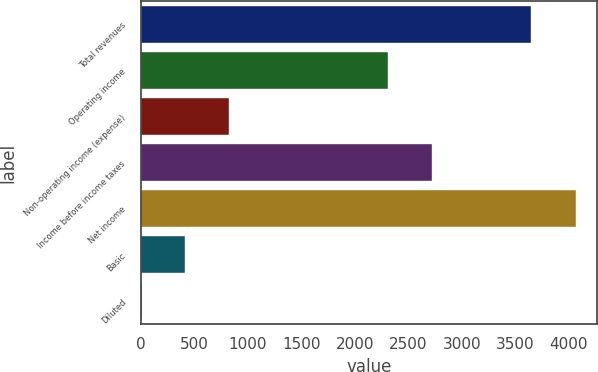<chart> <loc_0><loc_0><loc_500><loc_500><bar_chart><fcel>Total revenues<fcel>Operating income<fcel>Non-operating income (expense)<fcel>Income before income taxes<fcel>Net income<fcel>Basic<fcel>Diluted<nl><fcel>3644.7<fcel>2312<fcel>822.24<fcel>2717.15<fcel>4063.4<fcel>417.09<fcel>11.94<nl></chart> 